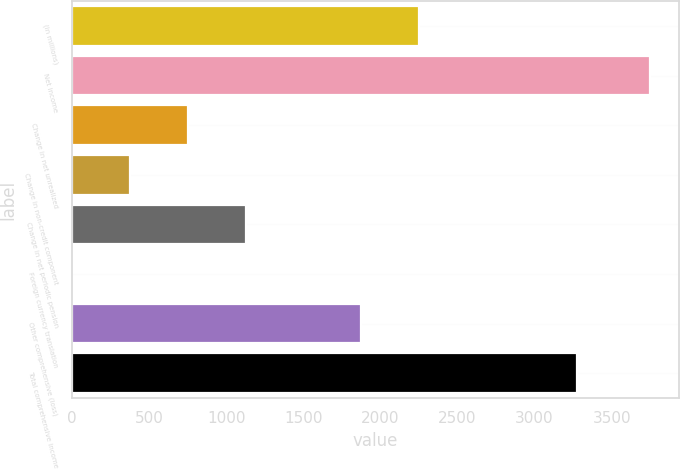Convert chart to OTSL. <chart><loc_0><loc_0><loc_500><loc_500><bar_chart><fcel>(in millions)<fcel>Net income<fcel>Change in net unrealized<fcel>Change in non-credit component<fcel>Change in net periodic pension<fcel>Foreign currency translation<fcel>Other comprehensive (loss)<fcel>Total comprehensive income<nl><fcel>2250.4<fcel>3750<fcel>750.8<fcel>375.9<fcel>1125.7<fcel>1<fcel>1875.5<fcel>3276<nl></chart> 